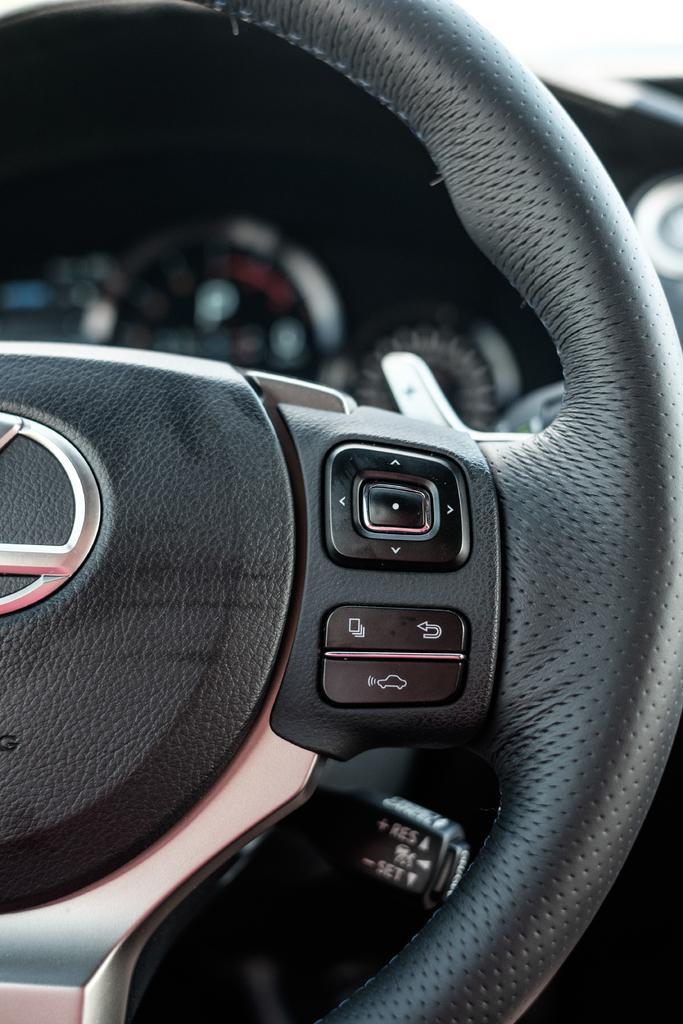Can you describe this image briefly? In this image we can see steering of a car with buttons. In the background it is blurry and we can see meters. 